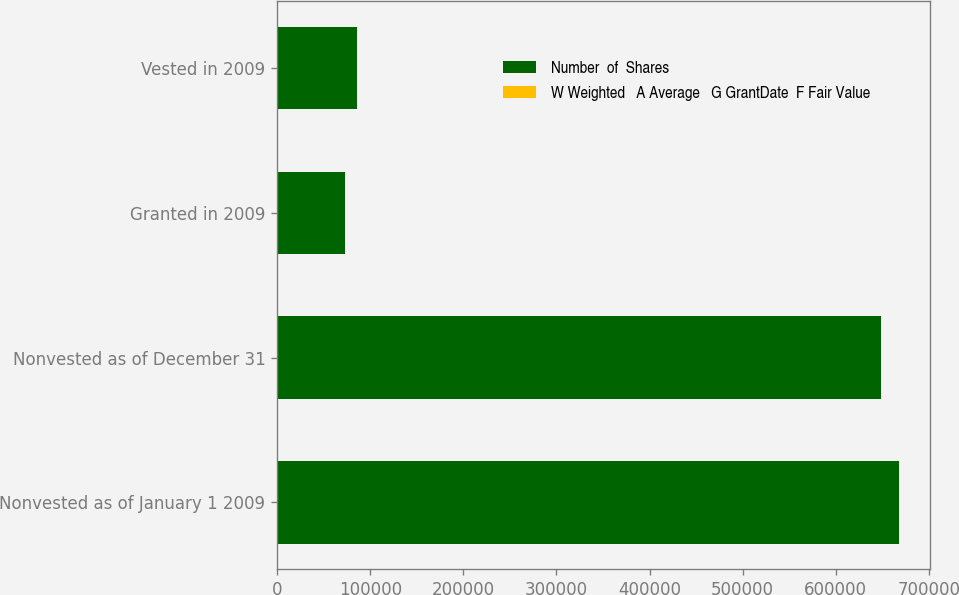Convert chart. <chart><loc_0><loc_0><loc_500><loc_500><stacked_bar_chart><ecel><fcel>Nonvested as of January 1 2009<fcel>Nonvested as of December 31<fcel>Granted in 2009<fcel>Vested in 2009<nl><fcel>Number  of  Shares<fcel>667933<fcel>648293<fcel>73255<fcel>85881<nl><fcel>W Weighted   A Average   G GrantDate  F Fair Value<fcel>49.54<fcel>48.84<fcel>43.68<fcel>42.73<nl></chart> 